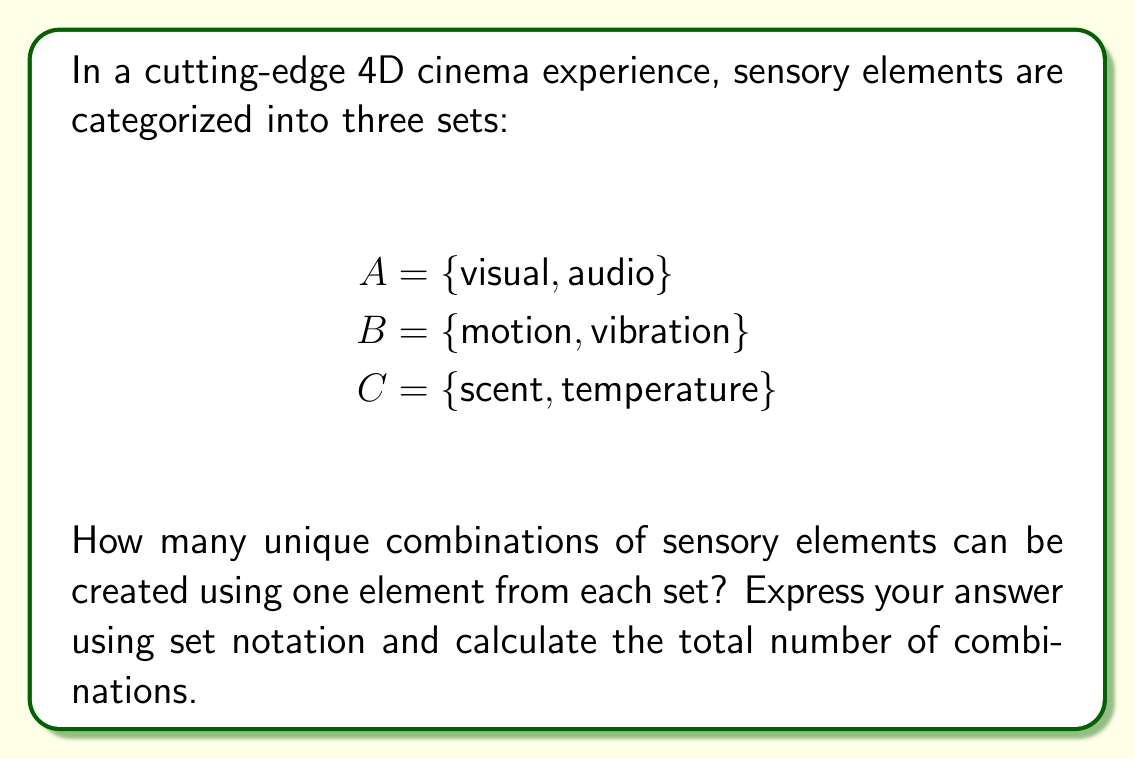Solve this math problem. To solve this problem, we need to understand the concept of Cartesian product and how it applies to the sensory elements in 4D cinema.

1. The Cartesian product of sets A, B, and C is denoted as $A \times B \times C$.

2. This product represents all possible combinations where we choose one element from each set.

3. The number of elements in the Cartesian product is equal to the product of the number of elements in each set:
   $|A \times B \times C| = |A| \cdot |B| \cdot |C|$

4. In this case:
   $|A| = 2$ (visual, audio)
   $|B| = 2$ (motion, vibration)
   $|C| = 2$ (scent, temperature)

5. Therefore, the total number of combinations is:
   $|A \times B \times C| = 2 \cdot 2 \cdot 2 = 8$

6. To express the Cartesian product using set notation:

   $A \times B \times C = \{(a, b, c) | a \in A, b \in B, c \in C\}$

   This means each element in the Cartesian product is an ordered triple $(a, b, c)$ where $a$ is from set A, $b$ is from set B, and $c$ is from set C.

7. Listing all combinations:
   (visual, motion, scent)
   (visual, motion, temperature)
   (visual, vibration, scent)
   (visual, vibration, temperature)
   (audio, motion, scent)
   (audio, motion, temperature)
   (audio, vibration, scent)
   (audio, vibration, temperature)

These combinations represent all possible ways to create a unique 4D cinema experience using one element from each sensory category.
Answer: $A \times B \times C = \{(a, b, c) | a \in A, b \in B, c \in C\}$

Total number of combinations: 8 